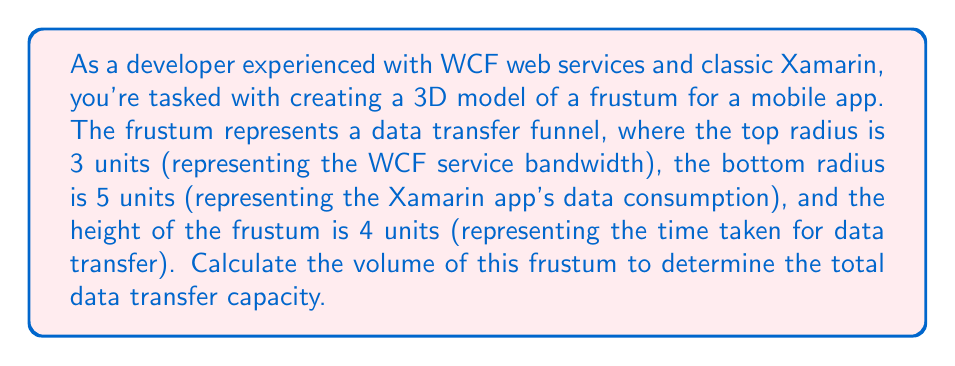Teach me how to tackle this problem. To solve this problem, we'll use the formula for the volume of a frustum:

$$V = \frac{1}{3}\pi h(R^2 + r^2 + Rr)$$

Where:
$V$ = volume of the frustum
$h$ = height of the frustum
$R$ = radius of the larger base
$r$ = radius of the smaller base

Given:
$h = 4$ units
$R = 5$ units (bottom radius)
$r = 3$ units (top radius)

Let's substitute these values into the formula:

$$V = \frac{1}{3}\pi \cdot 4(5^2 + 3^2 + 5 \cdot 3)$$

Now, let's solve step by step:

1) First, calculate the squared terms:
   $5^2 = 25$
   $3^2 = 9$

2) Multiply the radii:
   $5 \cdot 3 = 15$

3) Sum the terms inside the parentheses:
   $25 + 9 + 15 = 49$

4) Our equation now looks like:
   $$V = \frac{1}{3}\pi \cdot 4 \cdot 49$$

5) Multiply the numbers:
   $$V = \frac{4}{3}\pi \cdot 49 = \frac{196}{3}\pi$$

6) This can be simplified to:
   $$V = 65.3333...\pi$$

7) Multiply by $\pi$:
   $$V \approx 205.1327...$$

The volume is approximately 205.1327 cubic units.
Answer: The volume of the frustum is $\frac{196}{3}\pi$ or approximately 205.1327 cubic units. 